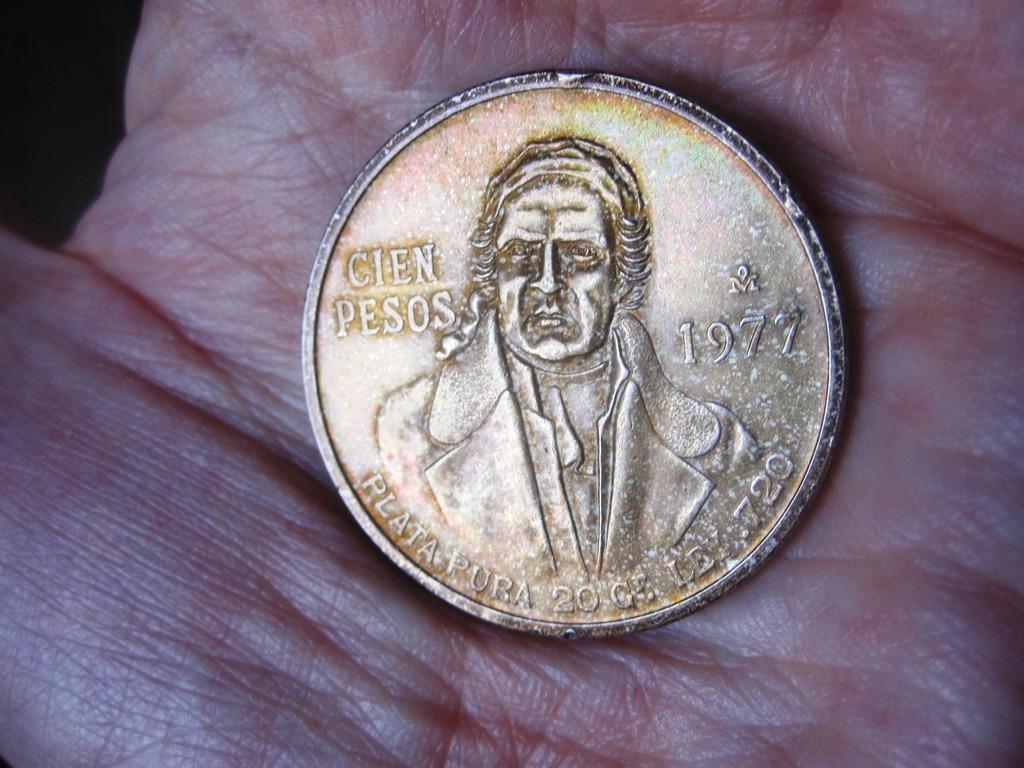<image>
Relay a brief, clear account of the picture shown. a golden coin that says 'cien pesos' on it and the year 1977 